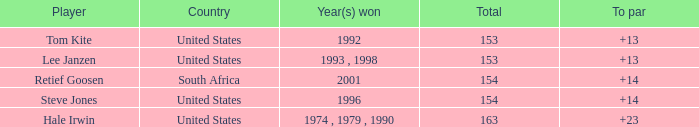What is the maximum to par that is below 153? None. 